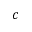<formula> <loc_0><loc_0><loc_500><loc_500>c</formula> 